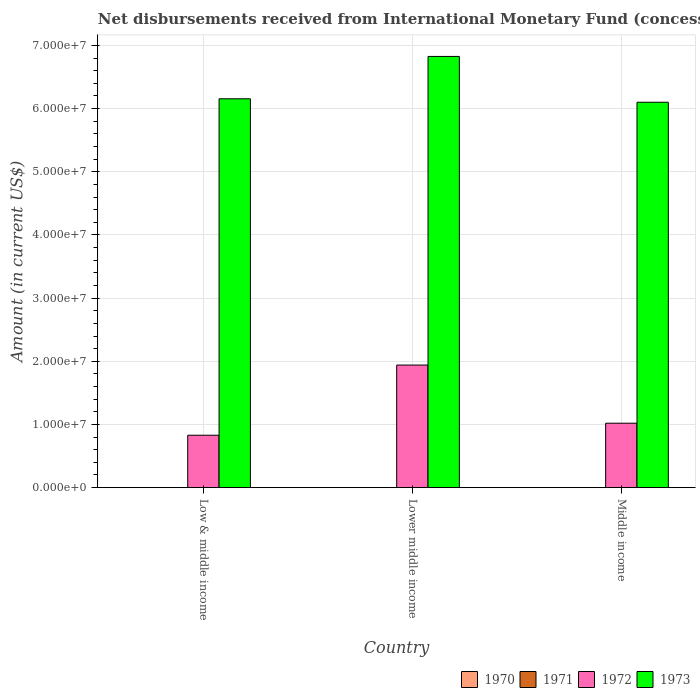Are the number of bars on each tick of the X-axis equal?
Offer a very short reply. Yes. How many bars are there on the 3rd tick from the left?
Make the answer very short. 2. How many bars are there on the 3rd tick from the right?
Provide a succinct answer. 2. What is the label of the 2nd group of bars from the left?
Offer a terse response. Lower middle income. Across all countries, what is the maximum amount of disbursements received from International Monetary Fund in 1973?
Provide a succinct answer. 6.83e+07. Across all countries, what is the minimum amount of disbursements received from International Monetary Fund in 1973?
Your response must be concise. 6.10e+07. In which country was the amount of disbursements received from International Monetary Fund in 1972 maximum?
Provide a short and direct response. Lower middle income. What is the total amount of disbursements received from International Monetary Fund in 1970 in the graph?
Your answer should be very brief. 0. What is the difference between the amount of disbursements received from International Monetary Fund in 1973 in Low & middle income and that in Lower middle income?
Make the answer very short. -6.70e+06. What is the difference between the amount of disbursements received from International Monetary Fund in 1971 in Low & middle income and the amount of disbursements received from International Monetary Fund in 1970 in Middle income?
Your answer should be compact. 0. What is the average amount of disbursements received from International Monetary Fund in 1972 per country?
Provide a short and direct response. 1.26e+07. What is the difference between the amount of disbursements received from International Monetary Fund of/in 1973 and amount of disbursements received from International Monetary Fund of/in 1972 in Middle income?
Your answer should be compact. 5.08e+07. What is the ratio of the amount of disbursements received from International Monetary Fund in 1973 in Low & middle income to that in Lower middle income?
Offer a very short reply. 0.9. Is the amount of disbursements received from International Monetary Fund in 1972 in Low & middle income less than that in Lower middle income?
Provide a succinct answer. Yes. Is the difference between the amount of disbursements received from International Monetary Fund in 1973 in Low & middle income and Middle income greater than the difference between the amount of disbursements received from International Monetary Fund in 1972 in Low & middle income and Middle income?
Your answer should be compact. Yes. What is the difference between the highest and the second highest amount of disbursements received from International Monetary Fund in 1973?
Your answer should be compact. -7.25e+06. What is the difference between the highest and the lowest amount of disbursements received from International Monetary Fund in 1973?
Provide a short and direct response. 7.25e+06. Is the sum of the amount of disbursements received from International Monetary Fund in 1972 in Lower middle income and Middle income greater than the maximum amount of disbursements received from International Monetary Fund in 1971 across all countries?
Provide a short and direct response. Yes. Is it the case that in every country, the sum of the amount of disbursements received from International Monetary Fund in 1971 and amount of disbursements received from International Monetary Fund in 1972 is greater than the sum of amount of disbursements received from International Monetary Fund in 1973 and amount of disbursements received from International Monetary Fund in 1970?
Provide a succinct answer. No. Is it the case that in every country, the sum of the amount of disbursements received from International Monetary Fund in 1973 and amount of disbursements received from International Monetary Fund in 1971 is greater than the amount of disbursements received from International Monetary Fund in 1972?
Provide a short and direct response. Yes. How many bars are there?
Your response must be concise. 6. Are all the bars in the graph horizontal?
Make the answer very short. No. How many countries are there in the graph?
Your response must be concise. 3. What is the difference between two consecutive major ticks on the Y-axis?
Make the answer very short. 1.00e+07. Does the graph contain grids?
Provide a short and direct response. Yes. What is the title of the graph?
Your response must be concise. Net disbursements received from International Monetary Fund (concessional). What is the Amount (in current US$) of 1971 in Low & middle income?
Provide a succinct answer. 0. What is the Amount (in current US$) of 1972 in Low & middle income?
Offer a terse response. 8.30e+06. What is the Amount (in current US$) in 1973 in Low & middle income?
Provide a succinct answer. 6.16e+07. What is the Amount (in current US$) in 1970 in Lower middle income?
Ensure brevity in your answer.  0. What is the Amount (in current US$) in 1971 in Lower middle income?
Your response must be concise. 0. What is the Amount (in current US$) in 1972 in Lower middle income?
Offer a terse response. 1.94e+07. What is the Amount (in current US$) in 1973 in Lower middle income?
Give a very brief answer. 6.83e+07. What is the Amount (in current US$) of 1970 in Middle income?
Offer a very short reply. 0. What is the Amount (in current US$) in 1972 in Middle income?
Ensure brevity in your answer.  1.02e+07. What is the Amount (in current US$) of 1973 in Middle income?
Make the answer very short. 6.10e+07. Across all countries, what is the maximum Amount (in current US$) of 1972?
Make the answer very short. 1.94e+07. Across all countries, what is the maximum Amount (in current US$) of 1973?
Your answer should be very brief. 6.83e+07. Across all countries, what is the minimum Amount (in current US$) of 1972?
Your answer should be very brief. 8.30e+06. Across all countries, what is the minimum Amount (in current US$) of 1973?
Offer a terse response. 6.10e+07. What is the total Amount (in current US$) of 1970 in the graph?
Provide a succinct answer. 0. What is the total Amount (in current US$) of 1971 in the graph?
Make the answer very short. 0. What is the total Amount (in current US$) in 1972 in the graph?
Offer a terse response. 3.79e+07. What is the total Amount (in current US$) of 1973 in the graph?
Provide a short and direct response. 1.91e+08. What is the difference between the Amount (in current US$) in 1972 in Low & middle income and that in Lower middle income?
Your answer should be compact. -1.11e+07. What is the difference between the Amount (in current US$) of 1973 in Low & middle income and that in Lower middle income?
Provide a succinct answer. -6.70e+06. What is the difference between the Amount (in current US$) of 1972 in Low & middle income and that in Middle income?
Make the answer very short. -1.90e+06. What is the difference between the Amount (in current US$) in 1973 in Low & middle income and that in Middle income?
Your answer should be compact. 5.46e+05. What is the difference between the Amount (in current US$) of 1972 in Lower middle income and that in Middle income?
Give a very brief answer. 9.21e+06. What is the difference between the Amount (in current US$) of 1973 in Lower middle income and that in Middle income?
Keep it short and to the point. 7.25e+06. What is the difference between the Amount (in current US$) in 1972 in Low & middle income and the Amount (in current US$) in 1973 in Lower middle income?
Provide a short and direct response. -6.00e+07. What is the difference between the Amount (in current US$) in 1972 in Low & middle income and the Amount (in current US$) in 1973 in Middle income?
Give a very brief answer. -5.27e+07. What is the difference between the Amount (in current US$) in 1972 in Lower middle income and the Amount (in current US$) in 1973 in Middle income?
Your answer should be compact. -4.16e+07. What is the average Amount (in current US$) of 1972 per country?
Your response must be concise. 1.26e+07. What is the average Amount (in current US$) of 1973 per country?
Offer a terse response. 6.36e+07. What is the difference between the Amount (in current US$) in 1972 and Amount (in current US$) in 1973 in Low & middle income?
Your response must be concise. -5.33e+07. What is the difference between the Amount (in current US$) in 1972 and Amount (in current US$) in 1973 in Lower middle income?
Keep it short and to the point. -4.89e+07. What is the difference between the Amount (in current US$) of 1972 and Amount (in current US$) of 1973 in Middle income?
Provide a succinct answer. -5.08e+07. What is the ratio of the Amount (in current US$) of 1972 in Low & middle income to that in Lower middle income?
Your answer should be very brief. 0.43. What is the ratio of the Amount (in current US$) in 1973 in Low & middle income to that in Lower middle income?
Offer a very short reply. 0.9. What is the ratio of the Amount (in current US$) in 1972 in Low & middle income to that in Middle income?
Offer a very short reply. 0.81. What is the ratio of the Amount (in current US$) in 1973 in Low & middle income to that in Middle income?
Make the answer very short. 1.01. What is the ratio of the Amount (in current US$) in 1972 in Lower middle income to that in Middle income?
Make the answer very short. 1.9. What is the ratio of the Amount (in current US$) of 1973 in Lower middle income to that in Middle income?
Make the answer very short. 1.12. What is the difference between the highest and the second highest Amount (in current US$) in 1972?
Your response must be concise. 9.21e+06. What is the difference between the highest and the second highest Amount (in current US$) of 1973?
Keep it short and to the point. 6.70e+06. What is the difference between the highest and the lowest Amount (in current US$) of 1972?
Keep it short and to the point. 1.11e+07. What is the difference between the highest and the lowest Amount (in current US$) in 1973?
Offer a very short reply. 7.25e+06. 